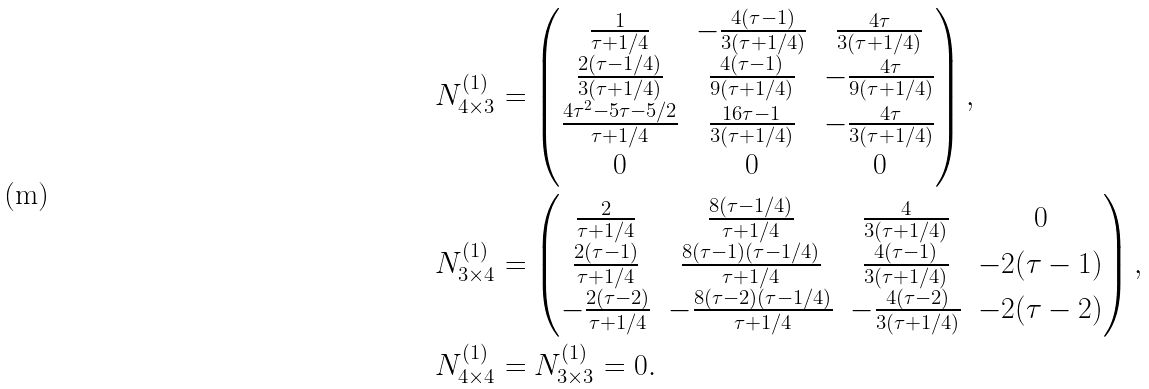Convert formula to latex. <formula><loc_0><loc_0><loc_500><loc_500>N ^ { ( 1 ) } _ { 4 \times 3 } & = \begin{pmatrix} \frac { 1 } { \tau + 1 / 4 } & - \frac { 4 ( \tau - 1 ) } { 3 ( \tau + 1 / 4 ) } & \frac { 4 \tau } { 3 ( \tau + 1 / 4 ) } \\ \frac { 2 ( \tau - 1 / 4 ) } { 3 ( \tau + 1 / 4 ) } & \frac { 4 ( \tau - 1 ) } { 9 ( \tau + 1 / 4 ) } & - \frac { 4 \tau } { 9 ( \tau + 1 / 4 ) } \\ \frac { 4 \tau ^ { 2 } - 5 \tau - 5 / 2 } { \tau + 1 / 4 } & \frac { 1 6 \tau - 1 } { 3 ( \tau + 1 / 4 ) } & - \frac { 4 \tau } { 3 ( \tau + 1 / 4 ) } \\ 0 & 0 & 0 \end{pmatrix} , \\ N ^ { ( 1 ) } _ { 3 \times 4 } & = \begin{pmatrix} \frac { 2 } { \tau + 1 / 4 } & \frac { 8 ( \tau - 1 / 4 ) } { \tau + 1 / 4 } & \frac { 4 } { 3 ( \tau + 1 / 4 ) } & 0 \\ \frac { 2 ( \tau - 1 ) } { \tau + 1 / 4 } & \frac { 8 ( \tau - 1 ) ( \tau - 1 / 4 ) } { \tau + 1 / 4 } & \frac { 4 ( \tau - 1 ) } { 3 ( \tau + 1 / 4 ) } & - 2 ( \tau - 1 ) \\ - \frac { 2 ( \tau - 2 ) } { \tau + 1 / 4 } & - \frac { 8 ( \tau - 2 ) ( \tau - 1 / 4 ) } { \tau + 1 / 4 } & - \frac { 4 ( \tau - 2 ) } { 3 ( \tau + 1 / 4 ) } & - 2 ( \tau - 2 ) \end{pmatrix} , \\ N ^ { ( 1 ) } _ { 4 \times 4 } & = N ^ { ( 1 ) } _ { 3 \times 3 } = 0 .</formula> 